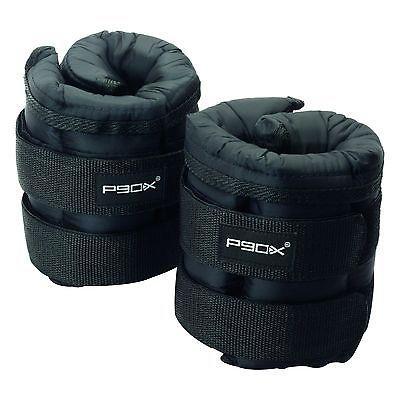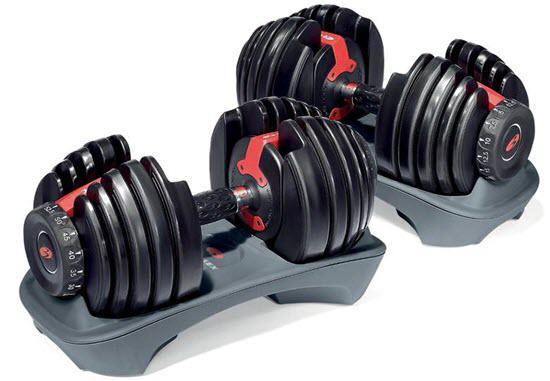The first image is the image on the left, the second image is the image on the right. Examine the images to the left and right. Is the description "Each image shows one overlapping pair of dumbbells, but the left image shows the overlapping dumbbell almost vertical, and the right image shows the overlapping dumbbell more diagonal." accurate? Answer yes or no. No. The first image is the image on the left, the second image is the image on the right. For the images shown, is this caption "The left and right image contains the same number of dumbells." true? Answer yes or no. No. 